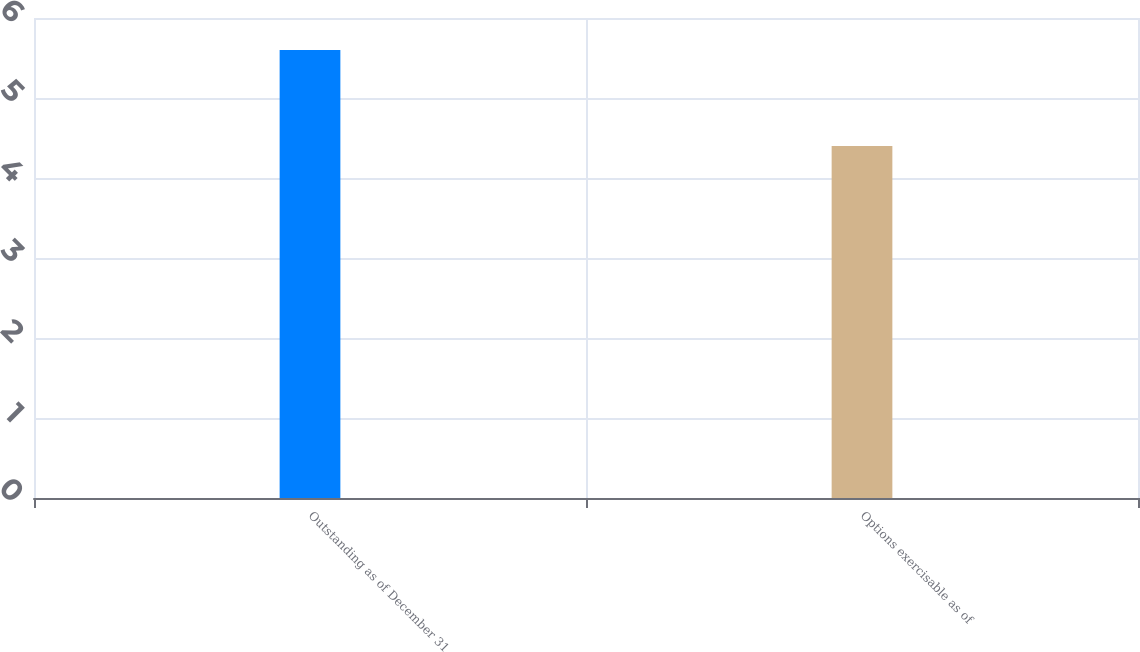<chart> <loc_0><loc_0><loc_500><loc_500><bar_chart><fcel>Outstanding as of December 31<fcel>Options exercisable as of<nl><fcel>5.6<fcel>4.4<nl></chart> 